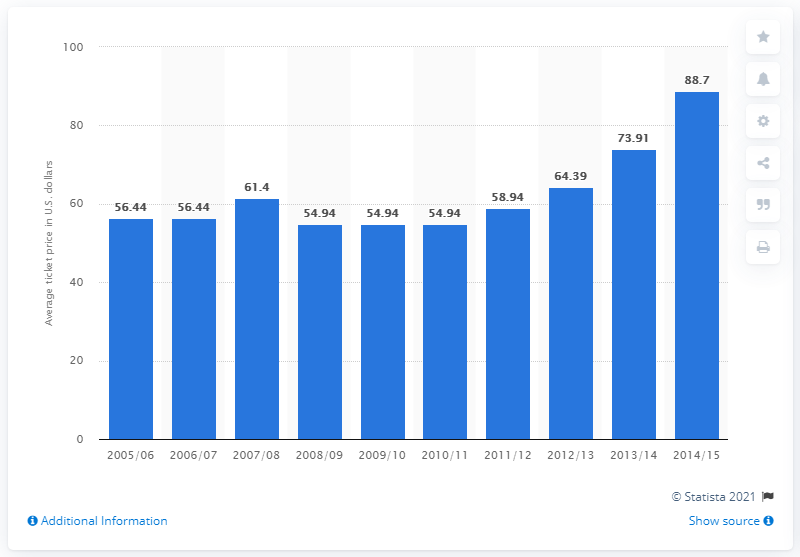Give some essential details in this illustration. The average ticket price for the 2005/06 season was 56.44 dollars. 